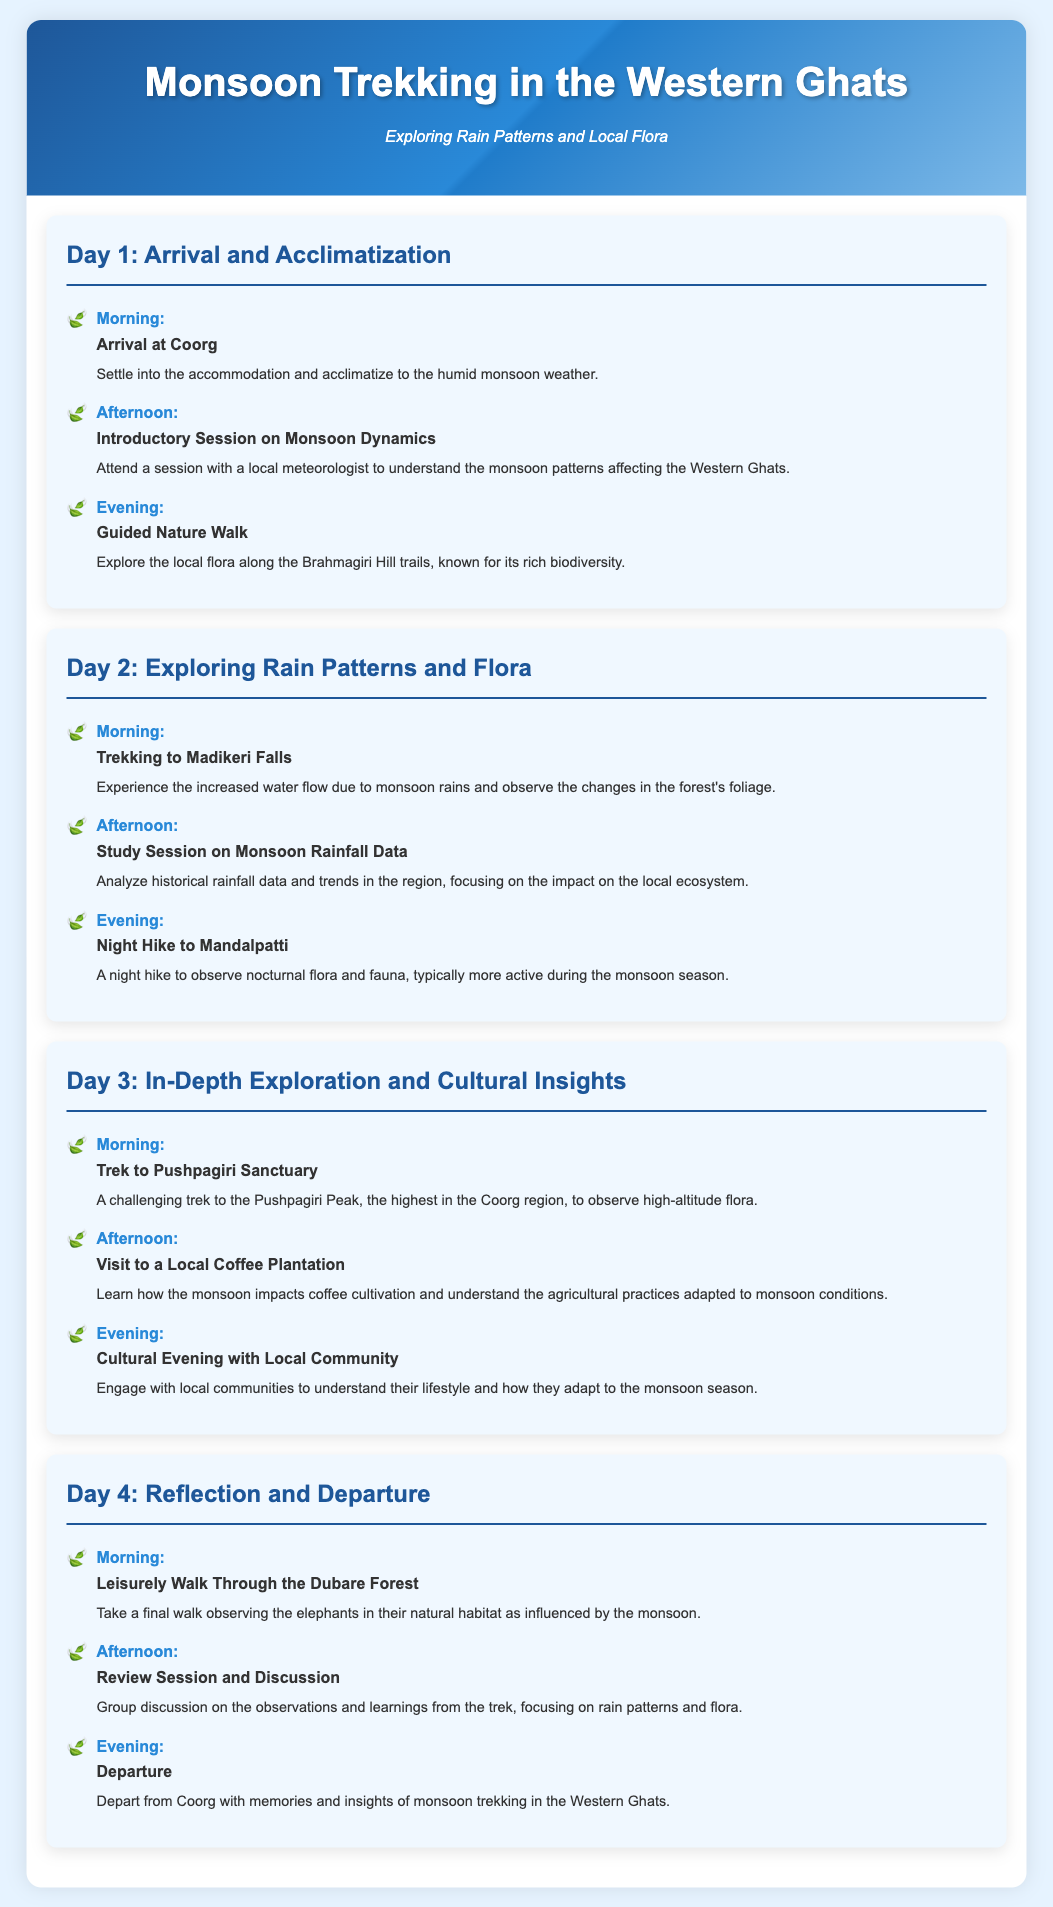What is the title of the itinerary? The title of the itinerary is prominently displayed at the top of the document.
Answer: Monsoon Trekking in the Western Ghats What is the first activity on Day 1? The first activity on Day 1 is listed with a specific time designation in the document.
Answer: Arrival at Coorg How many days does the itinerary cover? The document explicitly outlines the activities for each day, leading to the total number of days.
Answer: 4 What is the focus of the introductory session on Day 1? The description of the session indicates its content related to the monsoon.
Answer: Monsoon dynamics What activity is scheduled for the afternoon of Day 3? The document provides a clear structure for activities each day, listing times and descriptions.
Answer: Visit to a Local Coffee Plantation Which trek is highlighted on Day 2? The day's activities include specific treks that showcase the natural environment.
Answer: Trekking to Madikeri Falls What does the activity on Day 4 morning involve? The description in the document specifies the type of experience expected on that day.
Answer: Walk Through the Dubare Forest What is the last activity of the itinerary? The document reveals the final event of the trip in the evening of Day 4.
Answer: Departure 